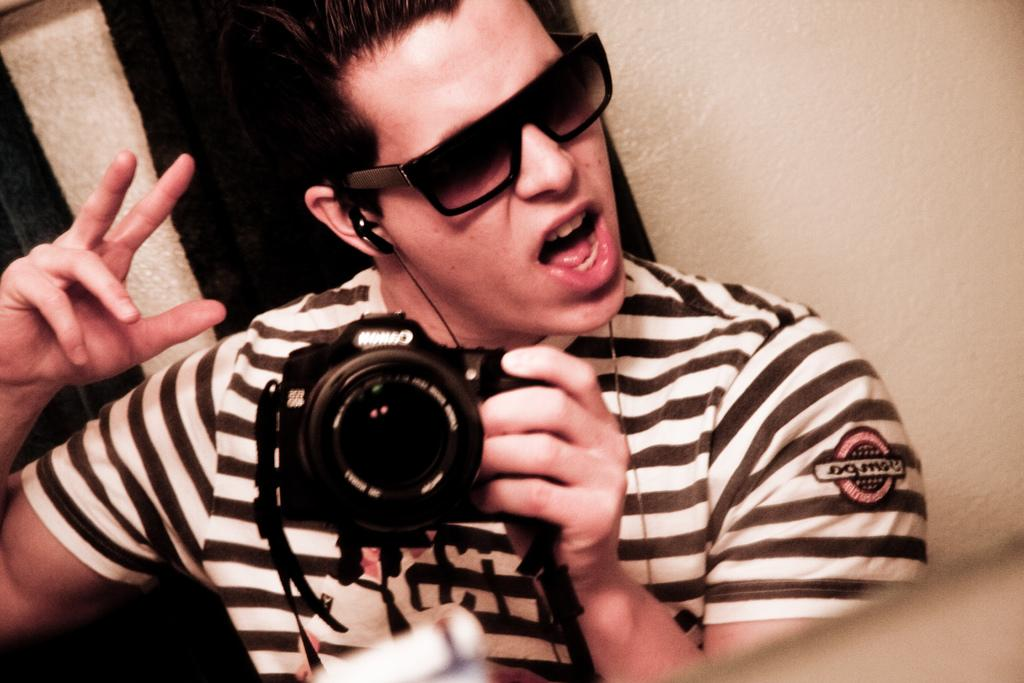Who is present in the image? There is a man in the image. What is the man wearing on his face? The man is wearing goggles. What is the man holding in his hands? The man is holding a camera. How many jewels can be seen on the man's shirt in the image? There are no jewels visible on the man's shirt in the image. What type of wheel is attached to the camera in the image? There is no wheel attached to the camera in the image. 